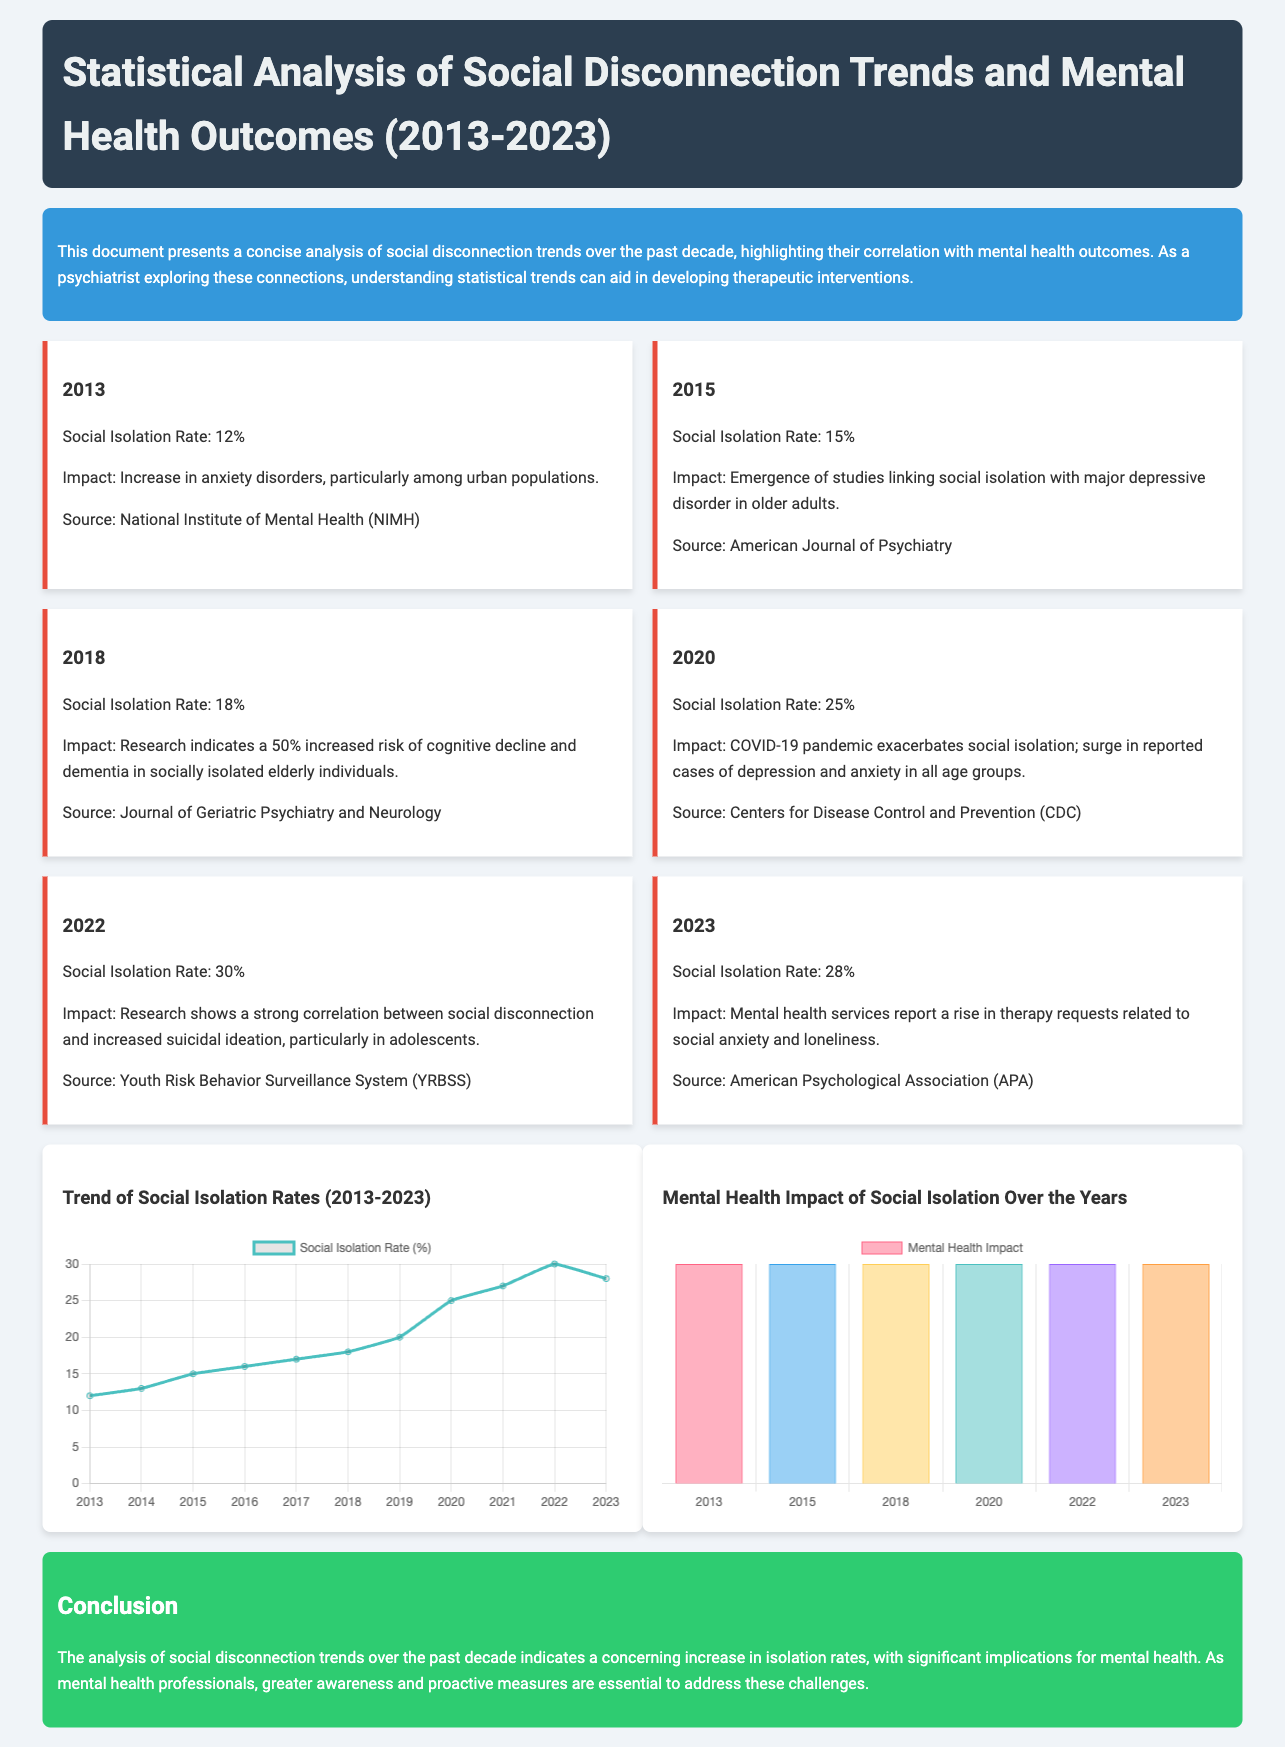What was the social isolation rate in 2013? The social isolation rate in 2013 is explicitly stated in the document as 12%.
Answer: 12% What impact was noted in 2018? The document mentions a 50% increased risk of cognitive decline and dementia in socially isolated elderly individuals as an impact noted in 2018.
Answer: Increased risk of cognitive decline and dementia What social isolation rate was reported in 2020? The specific social isolation rate for the year 2020 is given in the document, which is 25%.
Answer: 25% Which year exhibited a social isolation rate of 30%? The document shows that the year 2022 had a social isolation rate of 30%.
Answer: 2022 What correlation was highlighted in 2022? According to the document, the correlation highlighted in 2022 is between social disconnection and increased suicidal ideation, particularly in adolescents.
Answer: Increased suicidal ideation What was the trend in social isolation rates from 2013 to 2023? The document provides a line graph showing the trend of social isolation rates, indicating a general increase over the years.
Answer: General increase How did the COVID-19 pandemic affect social isolation? The document states that the COVID-19 pandemic exacerbated social isolation and contributed to a surge in reported cases of depression and anxiety.
Answer: Exacerbated social isolation What type of charts were used in the document? The document utilized a line chart for social isolation rates and a bar chart for mental health impact over the years.
Answer: Line chart and bar chart 